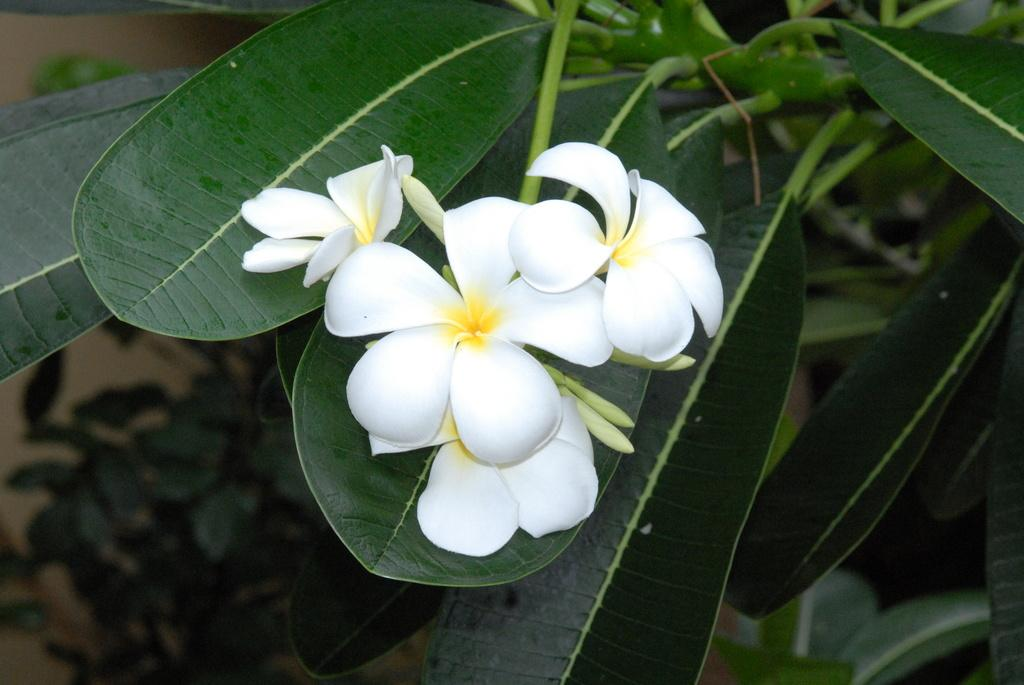What type of plant life is present in the image? There are flowers and leaves in the image. Can you describe the background of the image? There is a wall visible in the background of the image. Reasoning: Let' Let's think step by step in order to produce the conversation. We start by identifying the main subject in the image, which is the plant life. Then, we expand the conversation to include the background of the image. Each question is designed to elicit a specific detail about the image that is known from the provided facts. Absurd Question/Answer: Where is the park located in the image? There is no park present in the image; it only features flowers, leaves, and a wall in the background. What type of sponge is being used to clean the wall in the image? There is no sponge present in the image; it only features flowers, leaves, and a wall in the background. 